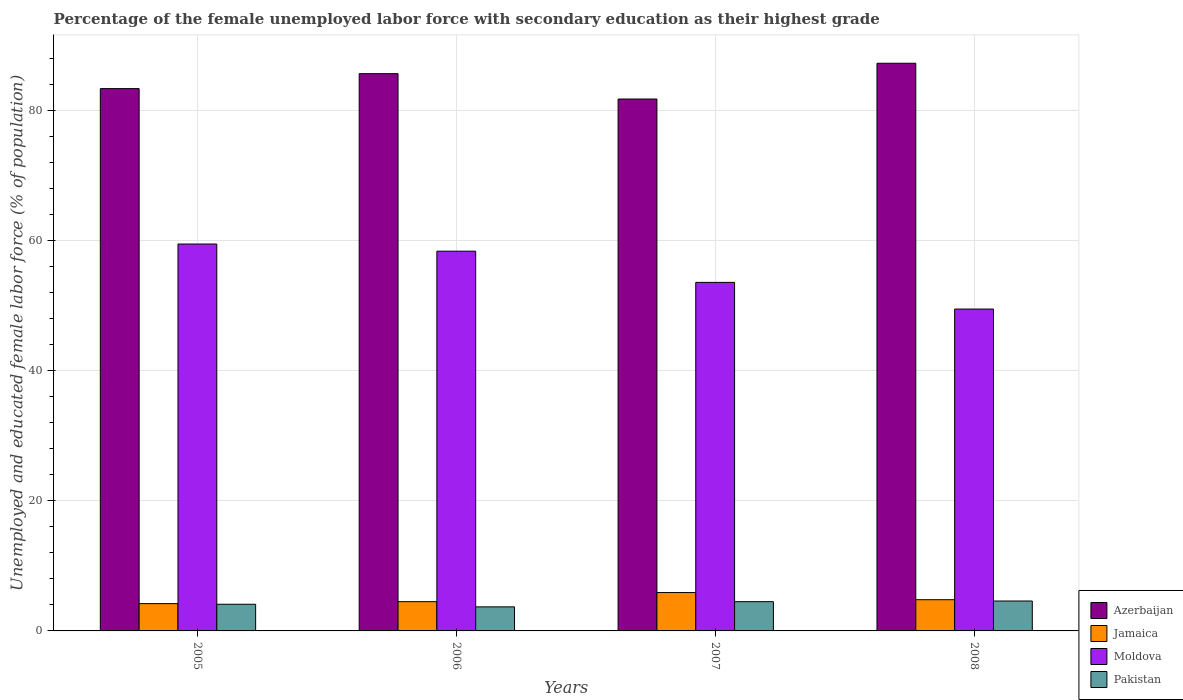How many different coloured bars are there?
Ensure brevity in your answer.  4. How many groups of bars are there?
Your answer should be very brief. 4. Are the number of bars on each tick of the X-axis equal?
Your answer should be compact. Yes. How many bars are there on the 3rd tick from the right?
Provide a short and direct response. 4. In how many cases, is the number of bars for a given year not equal to the number of legend labels?
Make the answer very short. 0. What is the percentage of the unemployed female labor force with secondary education in Pakistan in 2006?
Your response must be concise. 3.7. Across all years, what is the maximum percentage of the unemployed female labor force with secondary education in Azerbaijan?
Keep it short and to the point. 87.3. Across all years, what is the minimum percentage of the unemployed female labor force with secondary education in Moldova?
Provide a succinct answer. 49.5. In which year was the percentage of the unemployed female labor force with secondary education in Moldova maximum?
Provide a short and direct response. 2005. What is the total percentage of the unemployed female labor force with secondary education in Azerbaijan in the graph?
Ensure brevity in your answer.  338.2. What is the difference between the percentage of the unemployed female labor force with secondary education in Pakistan in 2006 and that in 2008?
Give a very brief answer. -0.9. What is the difference between the percentage of the unemployed female labor force with secondary education in Moldova in 2008 and the percentage of the unemployed female labor force with secondary education in Pakistan in 2006?
Offer a terse response. 45.8. What is the average percentage of the unemployed female labor force with secondary education in Azerbaijan per year?
Your answer should be very brief. 84.55. In the year 2006, what is the difference between the percentage of the unemployed female labor force with secondary education in Jamaica and percentage of the unemployed female labor force with secondary education in Azerbaijan?
Your answer should be compact. -81.2. In how many years, is the percentage of the unemployed female labor force with secondary education in Moldova greater than 44 %?
Provide a short and direct response. 4. What is the ratio of the percentage of the unemployed female labor force with secondary education in Moldova in 2005 to that in 2006?
Offer a terse response. 1.02. Is the percentage of the unemployed female labor force with secondary education in Pakistan in 2006 less than that in 2007?
Make the answer very short. Yes. Is the difference between the percentage of the unemployed female labor force with secondary education in Jamaica in 2005 and 2007 greater than the difference between the percentage of the unemployed female labor force with secondary education in Azerbaijan in 2005 and 2007?
Make the answer very short. No. What is the difference between the highest and the second highest percentage of the unemployed female labor force with secondary education in Azerbaijan?
Keep it short and to the point. 1.6. What is the difference between the highest and the lowest percentage of the unemployed female labor force with secondary education in Pakistan?
Offer a very short reply. 0.9. In how many years, is the percentage of the unemployed female labor force with secondary education in Jamaica greater than the average percentage of the unemployed female labor force with secondary education in Jamaica taken over all years?
Provide a short and direct response. 1. Is it the case that in every year, the sum of the percentage of the unemployed female labor force with secondary education in Moldova and percentage of the unemployed female labor force with secondary education in Azerbaijan is greater than the sum of percentage of the unemployed female labor force with secondary education in Pakistan and percentage of the unemployed female labor force with secondary education in Jamaica?
Offer a terse response. No. What does the 3rd bar from the left in 2008 represents?
Your answer should be compact. Moldova. What does the 1st bar from the right in 2008 represents?
Provide a succinct answer. Pakistan. Is it the case that in every year, the sum of the percentage of the unemployed female labor force with secondary education in Azerbaijan and percentage of the unemployed female labor force with secondary education in Pakistan is greater than the percentage of the unemployed female labor force with secondary education in Jamaica?
Make the answer very short. Yes. Are all the bars in the graph horizontal?
Keep it short and to the point. No. What is the difference between two consecutive major ticks on the Y-axis?
Offer a terse response. 20. Does the graph contain grids?
Your answer should be compact. Yes. How many legend labels are there?
Your answer should be very brief. 4. How are the legend labels stacked?
Provide a short and direct response. Vertical. What is the title of the graph?
Offer a very short reply. Percentage of the female unemployed labor force with secondary education as their highest grade. What is the label or title of the Y-axis?
Your answer should be very brief. Unemployed and educated female labor force (% of population). What is the Unemployed and educated female labor force (% of population) in Azerbaijan in 2005?
Keep it short and to the point. 83.4. What is the Unemployed and educated female labor force (% of population) of Jamaica in 2005?
Offer a very short reply. 4.2. What is the Unemployed and educated female labor force (% of population) in Moldova in 2005?
Provide a succinct answer. 59.5. What is the Unemployed and educated female labor force (% of population) in Pakistan in 2005?
Your answer should be very brief. 4.1. What is the Unemployed and educated female labor force (% of population) in Azerbaijan in 2006?
Give a very brief answer. 85.7. What is the Unemployed and educated female labor force (% of population) in Moldova in 2006?
Your response must be concise. 58.4. What is the Unemployed and educated female labor force (% of population) of Pakistan in 2006?
Your answer should be compact. 3.7. What is the Unemployed and educated female labor force (% of population) of Azerbaijan in 2007?
Offer a terse response. 81.8. What is the Unemployed and educated female labor force (% of population) of Jamaica in 2007?
Offer a very short reply. 5.9. What is the Unemployed and educated female labor force (% of population) in Moldova in 2007?
Ensure brevity in your answer.  53.6. What is the Unemployed and educated female labor force (% of population) in Pakistan in 2007?
Keep it short and to the point. 4.5. What is the Unemployed and educated female labor force (% of population) in Azerbaijan in 2008?
Make the answer very short. 87.3. What is the Unemployed and educated female labor force (% of population) of Jamaica in 2008?
Your response must be concise. 4.8. What is the Unemployed and educated female labor force (% of population) of Moldova in 2008?
Your response must be concise. 49.5. What is the Unemployed and educated female labor force (% of population) in Pakistan in 2008?
Offer a very short reply. 4.6. Across all years, what is the maximum Unemployed and educated female labor force (% of population) of Azerbaijan?
Make the answer very short. 87.3. Across all years, what is the maximum Unemployed and educated female labor force (% of population) in Jamaica?
Ensure brevity in your answer.  5.9. Across all years, what is the maximum Unemployed and educated female labor force (% of population) in Moldova?
Keep it short and to the point. 59.5. Across all years, what is the maximum Unemployed and educated female labor force (% of population) of Pakistan?
Offer a very short reply. 4.6. Across all years, what is the minimum Unemployed and educated female labor force (% of population) of Azerbaijan?
Ensure brevity in your answer.  81.8. Across all years, what is the minimum Unemployed and educated female labor force (% of population) in Jamaica?
Your answer should be compact. 4.2. Across all years, what is the minimum Unemployed and educated female labor force (% of population) in Moldova?
Make the answer very short. 49.5. Across all years, what is the minimum Unemployed and educated female labor force (% of population) of Pakistan?
Give a very brief answer. 3.7. What is the total Unemployed and educated female labor force (% of population) of Azerbaijan in the graph?
Offer a very short reply. 338.2. What is the total Unemployed and educated female labor force (% of population) of Jamaica in the graph?
Give a very brief answer. 19.4. What is the total Unemployed and educated female labor force (% of population) of Moldova in the graph?
Your answer should be compact. 221. What is the difference between the Unemployed and educated female labor force (% of population) in Azerbaijan in 2005 and that in 2006?
Offer a very short reply. -2.3. What is the difference between the Unemployed and educated female labor force (% of population) in Pakistan in 2005 and that in 2007?
Your answer should be compact. -0.4. What is the difference between the Unemployed and educated female labor force (% of population) of Azerbaijan in 2005 and that in 2008?
Provide a short and direct response. -3.9. What is the difference between the Unemployed and educated female labor force (% of population) in Pakistan in 2005 and that in 2008?
Keep it short and to the point. -0.5. What is the difference between the Unemployed and educated female labor force (% of population) in Azerbaijan in 2006 and that in 2007?
Your response must be concise. 3.9. What is the difference between the Unemployed and educated female labor force (% of population) in Moldova in 2006 and that in 2007?
Give a very brief answer. 4.8. What is the difference between the Unemployed and educated female labor force (% of population) of Pakistan in 2006 and that in 2007?
Your answer should be very brief. -0.8. What is the difference between the Unemployed and educated female labor force (% of population) of Azerbaijan in 2006 and that in 2008?
Make the answer very short. -1.6. What is the difference between the Unemployed and educated female labor force (% of population) in Jamaica in 2006 and that in 2008?
Provide a succinct answer. -0.3. What is the difference between the Unemployed and educated female labor force (% of population) in Moldova in 2006 and that in 2008?
Ensure brevity in your answer.  8.9. What is the difference between the Unemployed and educated female labor force (% of population) in Azerbaijan in 2007 and that in 2008?
Provide a succinct answer. -5.5. What is the difference between the Unemployed and educated female labor force (% of population) of Moldova in 2007 and that in 2008?
Provide a succinct answer. 4.1. What is the difference between the Unemployed and educated female labor force (% of population) in Pakistan in 2007 and that in 2008?
Keep it short and to the point. -0.1. What is the difference between the Unemployed and educated female labor force (% of population) of Azerbaijan in 2005 and the Unemployed and educated female labor force (% of population) of Jamaica in 2006?
Offer a very short reply. 78.9. What is the difference between the Unemployed and educated female labor force (% of population) of Azerbaijan in 2005 and the Unemployed and educated female labor force (% of population) of Pakistan in 2006?
Give a very brief answer. 79.7. What is the difference between the Unemployed and educated female labor force (% of population) of Jamaica in 2005 and the Unemployed and educated female labor force (% of population) of Moldova in 2006?
Ensure brevity in your answer.  -54.2. What is the difference between the Unemployed and educated female labor force (% of population) of Jamaica in 2005 and the Unemployed and educated female labor force (% of population) of Pakistan in 2006?
Your answer should be compact. 0.5. What is the difference between the Unemployed and educated female labor force (% of population) in Moldova in 2005 and the Unemployed and educated female labor force (% of population) in Pakistan in 2006?
Provide a short and direct response. 55.8. What is the difference between the Unemployed and educated female labor force (% of population) of Azerbaijan in 2005 and the Unemployed and educated female labor force (% of population) of Jamaica in 2007?
Your answer should be compact. 77.5. What is the difference between the Unemployed and educated female labor force (% of population) of Azerbaijan in 2005 and the Unemployed and educated female labor force (% of population) of Moldova in 2007?
Provide a succinct answer. 29.8. What is the difference between the Unemployed and educated female labor force (% of population) in Azerbaijan in 2005 and the Unemployed and educated female labor force (% of population) in Pakistan in 2007?
Provide a short and direct response. 78.9. What is the difference between the Unemployed and educated female labor force (% of population) of Jamaica in 2005 and the Unemployed and educated female labor force (% of population) of Moldova in 2007?
Give a very brief answer. -49.4. What is the difference between the Unemployed and educated female labor force (% of population) in Azerbaijan in 2005 and the Unemployed and educated female labor force (% of population) in Jamaica in 2008?
Give a very brief answer. 78.6. What is the difference between the Unemployed and educated female labor force (% of population) in Azerbaijan in 2005 and the Unemployed and educated female labor force (% of population) in Moldova in 2008?
Your answer should be compact. 33.9. What is the difference between the Unemployed and educated female labor force (% of population) in Azerbaijan in 2005 and the Unemployed and educated female labor force (% of population) in Pakistan in 2008?
Your answer should be compact. 78.8. What is the difference between the Unemployed and educated female labor force (% of population) in Jamaica in 2005 and the Unemployed and educated female labor force (% of population) in Moldova in 2008?
Provide a succinct answer. -45.3. What is the difference between the Unemployed and educated female labor force (% of population) of Moldova in 2005 and the Unemployed and educated female labor force (% of population) of Pakistan in 2008?
Your answer should be compact. 54.9. What is the difference between the Unemployed and educated female labor force (% of population) in Azerbaijan in 2006 and the Unemployed and educated female labor force (% of population) in Jamaica in 2007?
Your answer should be compact. 79.8. What is the difference between the Unemployed and educated female labor force (% of population) in Azerbaijan in 2006 and the Unemployed and educated female labor force (% of population) in Moldova in 2007?
Give a very brief answer. 32.1. What is the difference between the Unemployed and educated female labor force (% of population) of Azerbaijan in 2006 and the Unemployed and educated female labor force (% of population) of Pakistan in 2007?
Give a very brief answer. 81.2. What is the difference between the Unemployed and educated female labor force (% of population) of Jamaica in 2006 and the Unemployed and educated female labor force (% of population) of Moldova in 2007?
Give a very brief answer. -49.1. What is the difference between the Unemployed and educated female labor force (% of population) of Jamaica in 2006 and the Unemployed and educated female labor force (% of population) of Pakistan in 2007?
Your answer should be very brief. 0. What is the difference between the Unemployed and educated female labor force (% of population) of Moldova in 2006 and the Unemployed and educated female labor force (% of population) of Pakistan in 2007?
Your response must be concise. 53.9. What is the difference between the Unemployed and educated female labor force (% of population) in Azerbaijan in 2006 and the Unemployed and educated female labor force (% of population) in Jamaica in 2008?
Your response must be concise. 80.9. What is the difference between the Unemployed and educated female labor force (% of population) in Azerbaijan in 2006 and the Unemployed and educated female labor force (% of population) in Moldova in 2008?
Offer a very short reply. 36.2. What is the difference between the Unemployed and educated female labor force (% of population) of Azerbaijan in 2006 and the Unemployed and educated female labor force (% of population) of Pakistan in 2008?
Offer a very short reply. 81.1. What is the difference between the Unemployed and educated female labor force (% of population) of Jamaica in 2006 and the Unemployed and educated female labor force (% of population) of Moldova in 2008?
Provide a short and direct response. -45. What is the difference between the Unemployed and educated female labor force (% of population) of Jamaica in 2006 and the Unemployed and educated female labor force (% of population) of Pakistan in 2008?
Ensure brevity in your answer.  -0.1. What is the difference between the Unemployed and educated female labor force (% of population) of Moldova in 2006 and the Unemployed and educated female labor force (% of population) of Pakistan in 2008?
Your response must be concise. 53.8. What is the difference between the Unemployed and educated female labor force (% of population) in Azerbaijan in 2007 and the Unemployed and educated female labor force (% of population) in Moldova in 2008?
Your answer should be compact. 32.3. What is the difference between the Unemployed and educated female labor force (% of population) in Azerbaijan in 2007 and the Unemployed and educated female labor force (% of population) in Pakistan in 2008?
Make the answer very short. 77.2. What is the difference between the Unemployed and educated female labor force (% of population) in Jamaica in 2007 and the Unemployed and educated female labor force (% of population) in Moldova in 2008?
Your answer should be very brief. -43.6. What is the average Unemployed and educated female labor force (% of population) of Azerbaijan per year?
Provide a succinct answer. 84.55. What is the average Unemployed and educated female labor force (% of population) of Jamaica per year?
Keep it short and to the point. 4.85. What is the average Unemployed and educated female labor force (% of population) in Moldova per year?
Give a very brief answer. 55.25. What is the average Unemployed and educated female labor force (% of population) of Pakistan per year?
Your response must be concise. 4.22. In the year 2005, what is the difference between the Unemployed and educated female labor force (% of population) in Azerbaijan and Unemployed and educated female labor force (% of population) in Jamaica?
Offer a terse response. 79.2. In the year 2005, what is the difference between the Unemployed and educated female labor force (% of population) in Azerbaijan and Unemployed and educated female labor force (% of population) in Moldova?
Keep it short and to the point. 23.9. In the year 2005, what is the difference between the Unemployed and educated female labor force (% of population) in Azerbaijan and Unemployed and educated female labor force (% of population) in Pakistan?
Your response must be concise. 79.3. In the year 2005, what is the difference between the Unemployed and educated female labor force (% of population) in Jamaica and Unemployed and educated female labor force (% of population) in Moldova?
Your answer should be compact. -55.3. In the year 2005, what is the difference between the Unemployed and educated female labor force (% of population) of Jamaica and Unemployed and educated female labor force (% of population) of Pakistan?
Your answer should be very brief. 0.1. In the year 2005, what is the difference between the Unemployed and educated female labor force (% of population) of Moldova and Unemployed and educated female labor force (% of population) of Pakistan?
Give a very brief answer. 55.4. In the year 2006, what is the difference between the Unemployed and educated female labor force (% of population) of Azerbaijan and Unemployed and educated female labor force (% of population) of Jamaica?
Your answer should be compact. 81.2. In the year 2006, what is the difference between the Unemployed and educated female labor force (% of population) of Azerbaijan and Unemployed and educated female labor force (% of population) of Moldova?
Your answer should be very brief. 27.3. In the year 2006, what is the difference between the Unemployed and educated female labor force (% of population) of Azerbaijan and Unemployed and educated female labor force (% of population) of Pakistan?
Keep it short and to the point. 82. In the year 2006, what is the difference between the Unemployed and educated female labor force (% of population) of Jamaica and Unemployed and educated female labor force (% of population) of Moldova?
Offer a terse response. -53.9. In the year 2006, what is the difference between the Unemployed and educated female labor force (% of population) in Jamaica and Unemployed and educated female labor force (% of population) in Pakistan?
Keep it short and to the point. 0.8. In the year 2006, what is the difference between the Unemployed and educated female labor force (% of population) in Moldova and Unemployed and educated female labor force (% of population) in Pakistan?
Provide a succinct answer. 54.7. In the year 2007, what is the difference between the Unemployed and educated female labor force (% of population) of Azerbaijan and Unemployed and educated female labor force (% of population) of Jamaica?
Ensure brevity in your answer.  75.9. In the year 2007, what is the difference between the Unemployed and educated female labor force (% of population) of Azerbaijan and Unemployed and educated female labor force (% of population) of Moldova?
Provide a short and direct response. 28.2. In the year 2007, what is the difference between the Unemployed and educated female labor force (% of population) of Azerbaijan and Unemployed and educated female labor force (% of population) of Pakistan?
Offer a very short reply. 77.3. In the year 2007, what is the difference between the Unemployed and educated female labor force (% of population) in Jamaica and Unemployed and educated female labor force (% of population) in Moldova?
Give a very brief answer. -47.7. In the year 2007, what is the difference between the Unemployed and educated female labor force (% of population) in Jamaica and Unemployed and educated female labor force (% of population) in Pakistan?
Your answer should be compact. 1.4. In the year 2007, what is the difference between the Unemployed and educated female labor force (% of population) of Moldova and Unemployed and educated female labor force (% of population) of Pakistan?
Keep it short and to the point. 49.1. In the year 2008, what is the difference between the Unemployed and educated female labor force (% of population) in Azerbaijan and Unemployed and educated female labor force (% of population) in Jamaica?
Your response must be concise. 82.5. In the year 2008, what is the difference between the Unemployed and educated female labor force (% of population) in Azerbaijan and Unemployed and educated female labor force (% of population) in Moldova?
Your response must be concise. 37.8. In the year 2008, what is the difference between the Unemployed and educated female labor force (% of population) in Azerbaijan and Unemployed and educated female labor force (% of population) in Pakistan?
Your answer should be compact. 82.7. In the year 2008, what is the difference between the Unemployed and educated female labor force (% of population) of Jamaica and Unemployed and educated female labor force (% of population) of Moldova?
Provide a short and direct response. -44.7. In the year 2008, what is the difference between the Unemployed and educated female labor force (% of population) of Moldova and Unemployed and educated female labor force (% of population) of Pakistan?
Your answer should be very brief. 44.9. What is the ratio of the Unemployed and educated female labor force (% of population) in Azerbaijan in 2005 to that in 2006?
Provide a succinct answer. 0.97. What is the ratio of the Unemployed and educated female labor force (% of population) of Jamaica in 2005 to that in 2006?
Offer a very short reply. 0.93. What is the ratio of the Unemployed and educated female labor force (% of population) of Moldova in 2005 to that in 2006?
Offer a very short reply. 1.02. What is the ratio of the Unemployed and educated female labor force (% of population) of Pakistan in 2005 to that in 2006?
Your answer should be very brief. 1.11. What is the ratio of the Unemployed and educated female labor force (% of population) of Azerbaijan in 2005 to that in 2007?
Ensure brevity in your answer.  1.02. What is the ratio of the Unemployed and educated female labor force (% of population) of Jamaica in 2005 to that in 2007?
Your answer should be very brief. 0.71. What is the ratio of the Unemployed and educated female labor force (% of population) of Moldova in 2005 to that in 2007?
Make the answer very short. 1.11. What is the ratio of the Unemployed and educated female labor force (% of population) of Pakistan in 2005 to that in 2007?
Offer a very short reply. 0.91. What is the ratio of the Unemployed and educated female labor force (% of population) of Azerbaijan in 2005 to that in 2008?
Your answer should be very brief. 0.96. What is the ratio of the Unemployed and educated female labor force (% of population) in Jamaica in 2005 to that in 2008?
Make the answer very short. 0.88. What is the ratio of the Unemployed and educated female labor force (% of population) in Moldova in 2005 to that in 2008?
Your answer should be very brief. 1.2. What is the ratio of the Unemployed and educated female labor force (% of population) in Pakistan in 2005 to that in 2008?
Keep it short and to the point. 0.89. What is the ratio of the Unemployed and educated female labor force (% of population) of Azerbaijan in 2006 to that in 2007?
Offer a very short reply. 1.05. What is the ratio of the Unemployed and educated female labor force (% of population) in Jamaica in 2006 to that in 2007?
Provide a succinct answer. 0.76. What is the ratio of the Unemployed and educated female labor force (% of population) of Moldova in 2006 to that in 2007?
Your response must be concise. 1.09. What is the ratio of the Unemployed and educated female labor force (% of population) of Pakistan in 2006 to that in 2007?
Give a very brief answer. 0.82. What is the ratio of the Unemployed and educated female labor force (% of population) in Azerbaijan in 2006 to that in 2008?
Make the answer very short. 0.98. What is the ratio of the Unemployed and educated female labor force (% of population) of Moldova in 2006 to that in 2008?
Offer a very short reply. 1.18. What is the ratio of the Unemployed and educated female labor force (% of population) of Pakistan in 2006 to that in 2008?
Offer a very short reply. 0.8. What is the ratio of the Unemployed and educated female labor force (% of population) of Azerbaijan in 2007 to that in 2008?
Offer a very short reply. 0.94. What is the ratio of the Unemployed and educated female labor force (% of population) in Jamaica in 2007 to that in 2008?
Provide a succinct answer. 1.23. What is the ratio of the Unemployed and educated female labor force (% of population) in Moldova in 2007 to that in 2008?
Your answer should be compact. 1.08. What is the ratio of the Unemployed and educated female labor force (% of population) of Pakistan in 2007 to that in 2008?
Provide a succinct answer. 0.98. What is the difference between the highest and the second highest Unemployed and educated female labor force (% of population) in Azerbaijan?
Ensure brevity in your answer.  1.6. What is the difference between the highest and the second highest Unemployed and educated female labor force (% of population) in Moldova?
Provide a succinct answer. 1.1. What is the difference between the highest and the second highest Unemployed and educated female labor force (% of population) in Pakistan?
Make the answer very short. 0.1. What is the difference between the highest and the lowest Unemployed and educated female labor force (% of population) in Azerbaijan?
Provide a short and direct response. 5.5. 